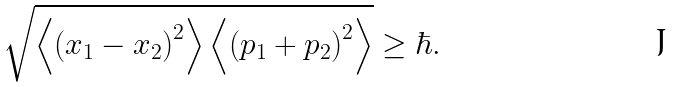<formula> <loc_0><loc_0><loc_500><loc_500>\sqrt { \left \langle \left ( x _ { 1 } - x _ { 2 } \right ) ^ { 2 } \right \rangle \left \langle \left ( p _ { 1 } + p _ { 2 } \right ) ^ { 2 } \right \rangle } \geq \hbar { . }</formula> 